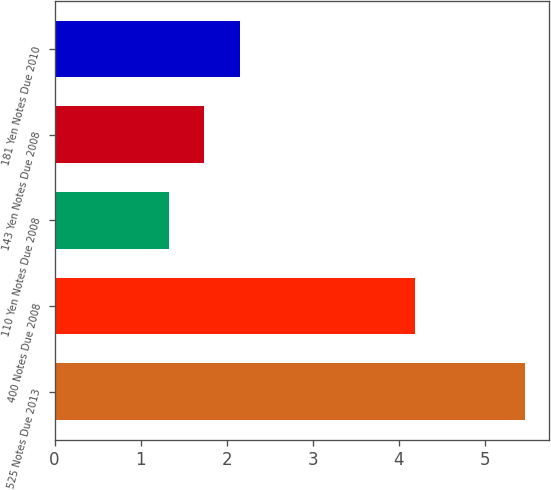Convert chart. <chart><loc_0><loc_0><loc_500><loc_500><bar_chart><fcel>525 Notes Due 2013<fcel>400 Notes Due 2008<fcel>110 Yen Notes Due 2008<fcel>143 Yen Notes Due 2008<fcel>181 Yen Notes Due 2010<nl><fcel>5.47<fcel>4.19<fcel>1.33<fcel>1.74<fcel>2.15<nl></chart> 